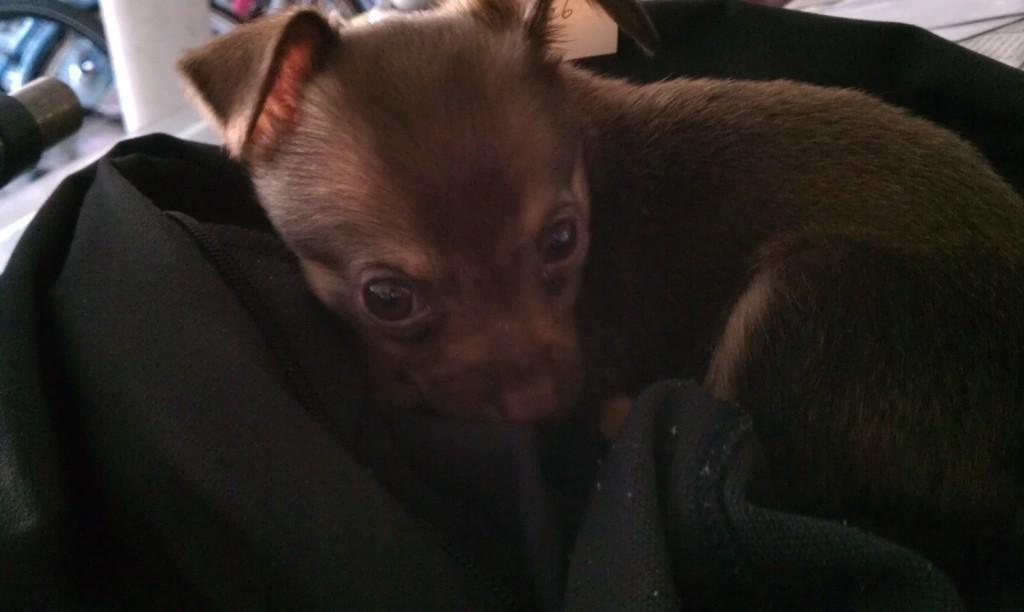In one or two sentences, can you explain what this image depicts? In the center of the image there is a dog on a black color cloth. 